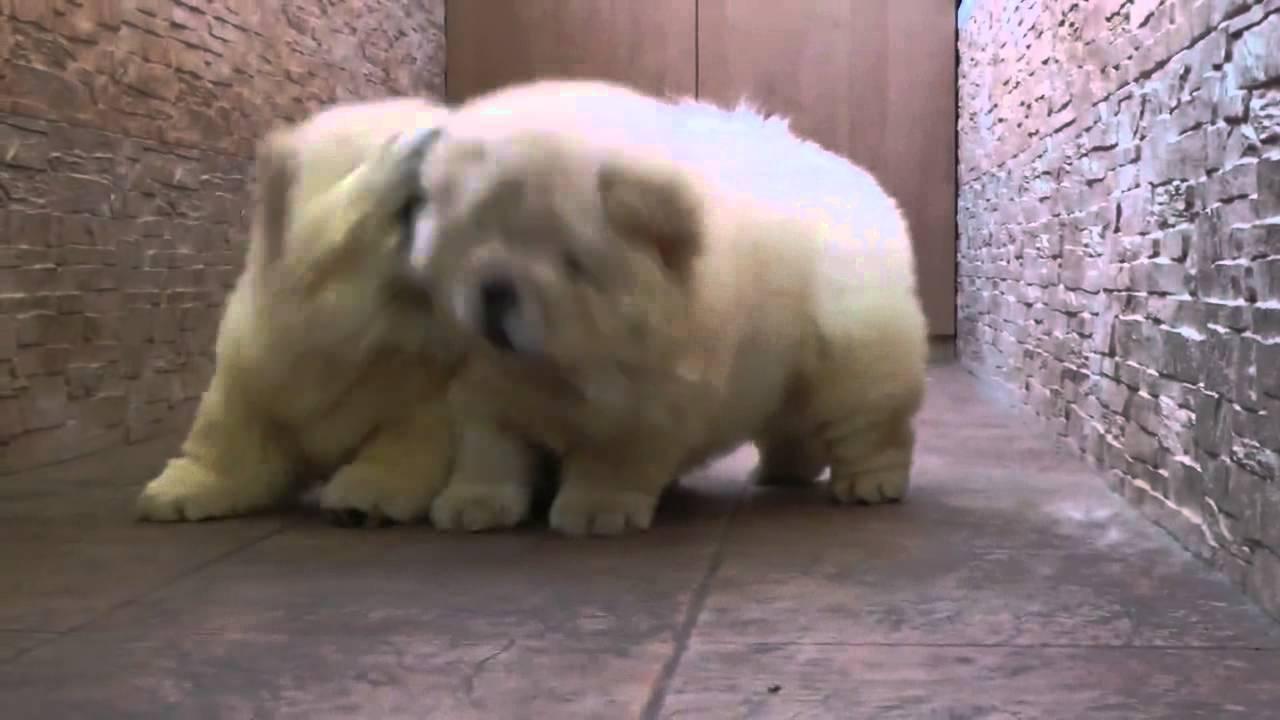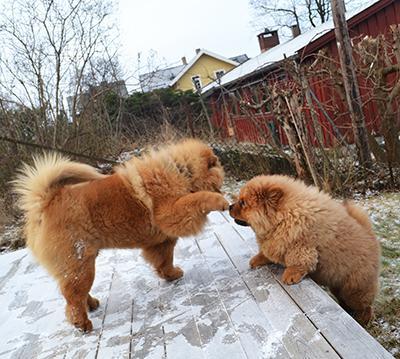The first image is the image on the left, the second image is the image on the right. For the images shown, is this caption "There are no less than four dogs in one of the images." true? Answer yes or no. No. The first image is the image on the left, the second image is the image on the right. Given the left and right images, does the statement "There are more than 4 dogs." hold true? Answer yes or no. No. 